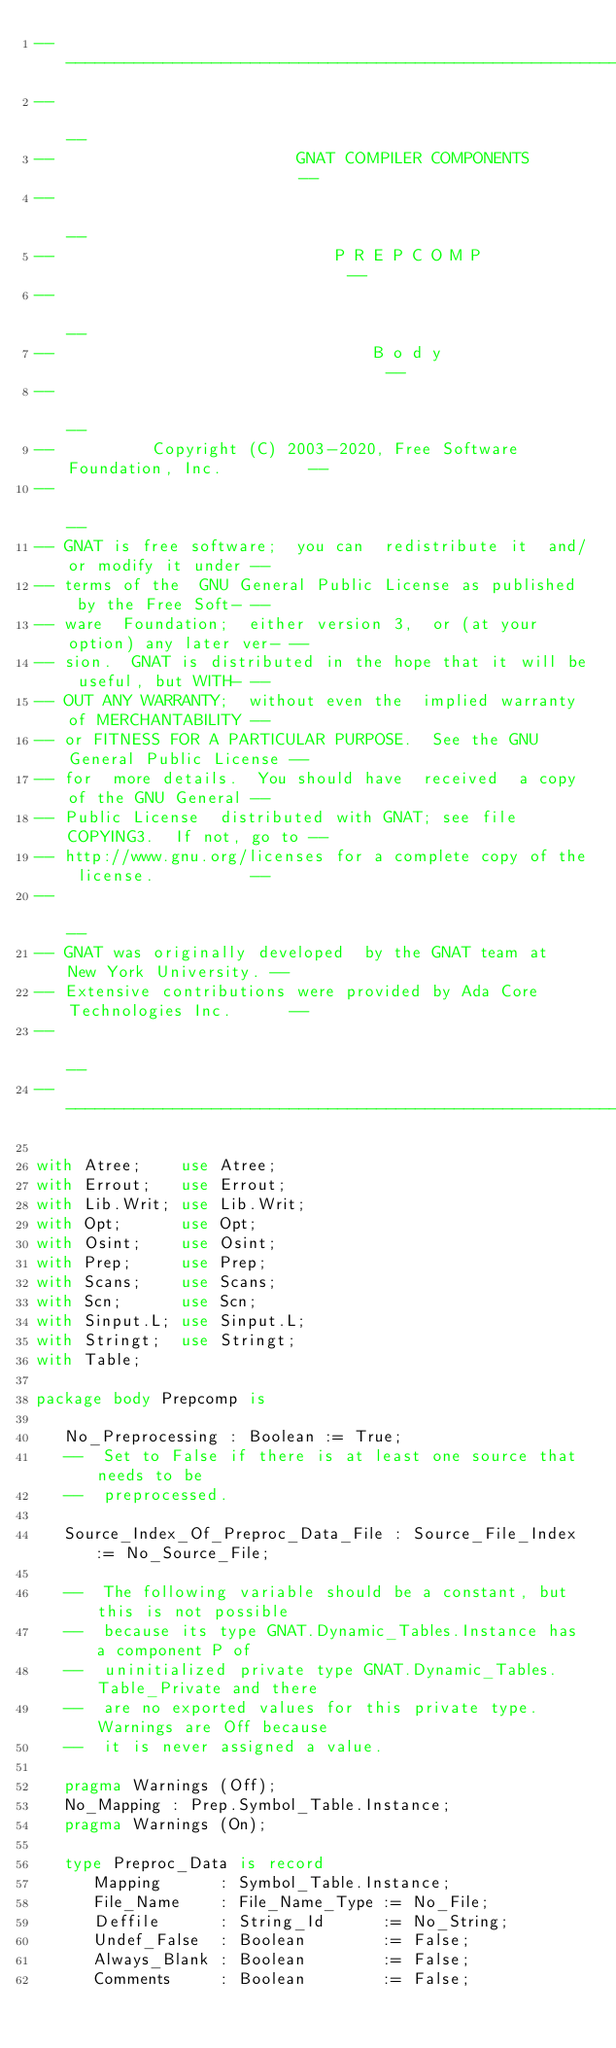Convert code to text. <code><loc_0><loc_0><loc_500><loc_500><_Ada_>------------------------------------------------------------------------------
--                                                                          --
--                         GNAT COMPILER COMPONENTS                         --
--                                                                          --
--                             P R E P C O M P                              --
--                                                                          --
--                                 B o d y                                  --
--                                                                          --
--          Copyright (C) 2003-2020, Free Software Foundation, Inc.         --
--                                                                          --
-- GNAT is free software;  you can  redistribute it  and/or modify it under --
-- terms of the  GNU General Public License as published  by the Free Soft- --
-- ware  Foundation;  either version 3,  or (at your option) any later ver- --
-- sion.  GNAT is distributed in the hope that it will be useful, but WITH- --
-- OUT ANY WARRANTY;  without even the  implied warranty of MERCHANTABILITY --
-- or FITNESS FOR A PARTICULAR PURPOSE.  See the GNU General Public License --
-- for  more details.  You should have  received  a copy of the GNU General --
-- Public License  distributed with GNAT; see file COPYING3.  If not, go to --
-- http://www.gnu.org/licenses for a complete copy of the license.          --
--                                                                          --
-- GNAT was originally developed  by the GNAT team at  New York University. --
-- Extensive contributions were provided by Ada Core Technologies Inc.      --
--                                                                          --
------------------------------------------------------------------------------

with Atree;    use Atree;
with Errout;   use Errout;
with Lib.Writ; use Lib.Writ;
with Opt;      use Opt;
with Osint;    use Osint;
with Prep;     use Prep;
with Scans;    use Scans;
with Scn;      use Scn;
with Sinput.L; use Sinput.L;
with Stringt;  use Stringt;
with Table;

package body Prepcomp is

   No_Preprocessing : Boolean := True;
   --  Set to False if there is at least one source that needs to be
   --  preprocessed.

   Source_Index_Of_Preproc_Data_File : Source_File_Index := No_Source_File;

   --  The following variable should be a constant, but this is not possible
   --  because its type GNAT.Dynamic_Tables.Instance has a component P of
   --  uninitialized private type GNAT.Dynamic_Tables.Table_Private and there
   --  are no exported values for this private type. Warnings are Off because
   --  it is never assigned a value.

   pragma Warnings (Off);
   No_Mapping : Prep.Symbol_Table.Instance;
   pragma Warnings (On);

   type Preproc_Data is record
      Mapping      : Symbol_Table.Instance;
      File_Name    : File_Name_Type := No_File;
      Deffile      : String_Id      := No_String;
      Undef_False  : Boolean        := False;
      Always_Blank : Boolean        := False;
      Comments     : Boolean        := False;</code> 